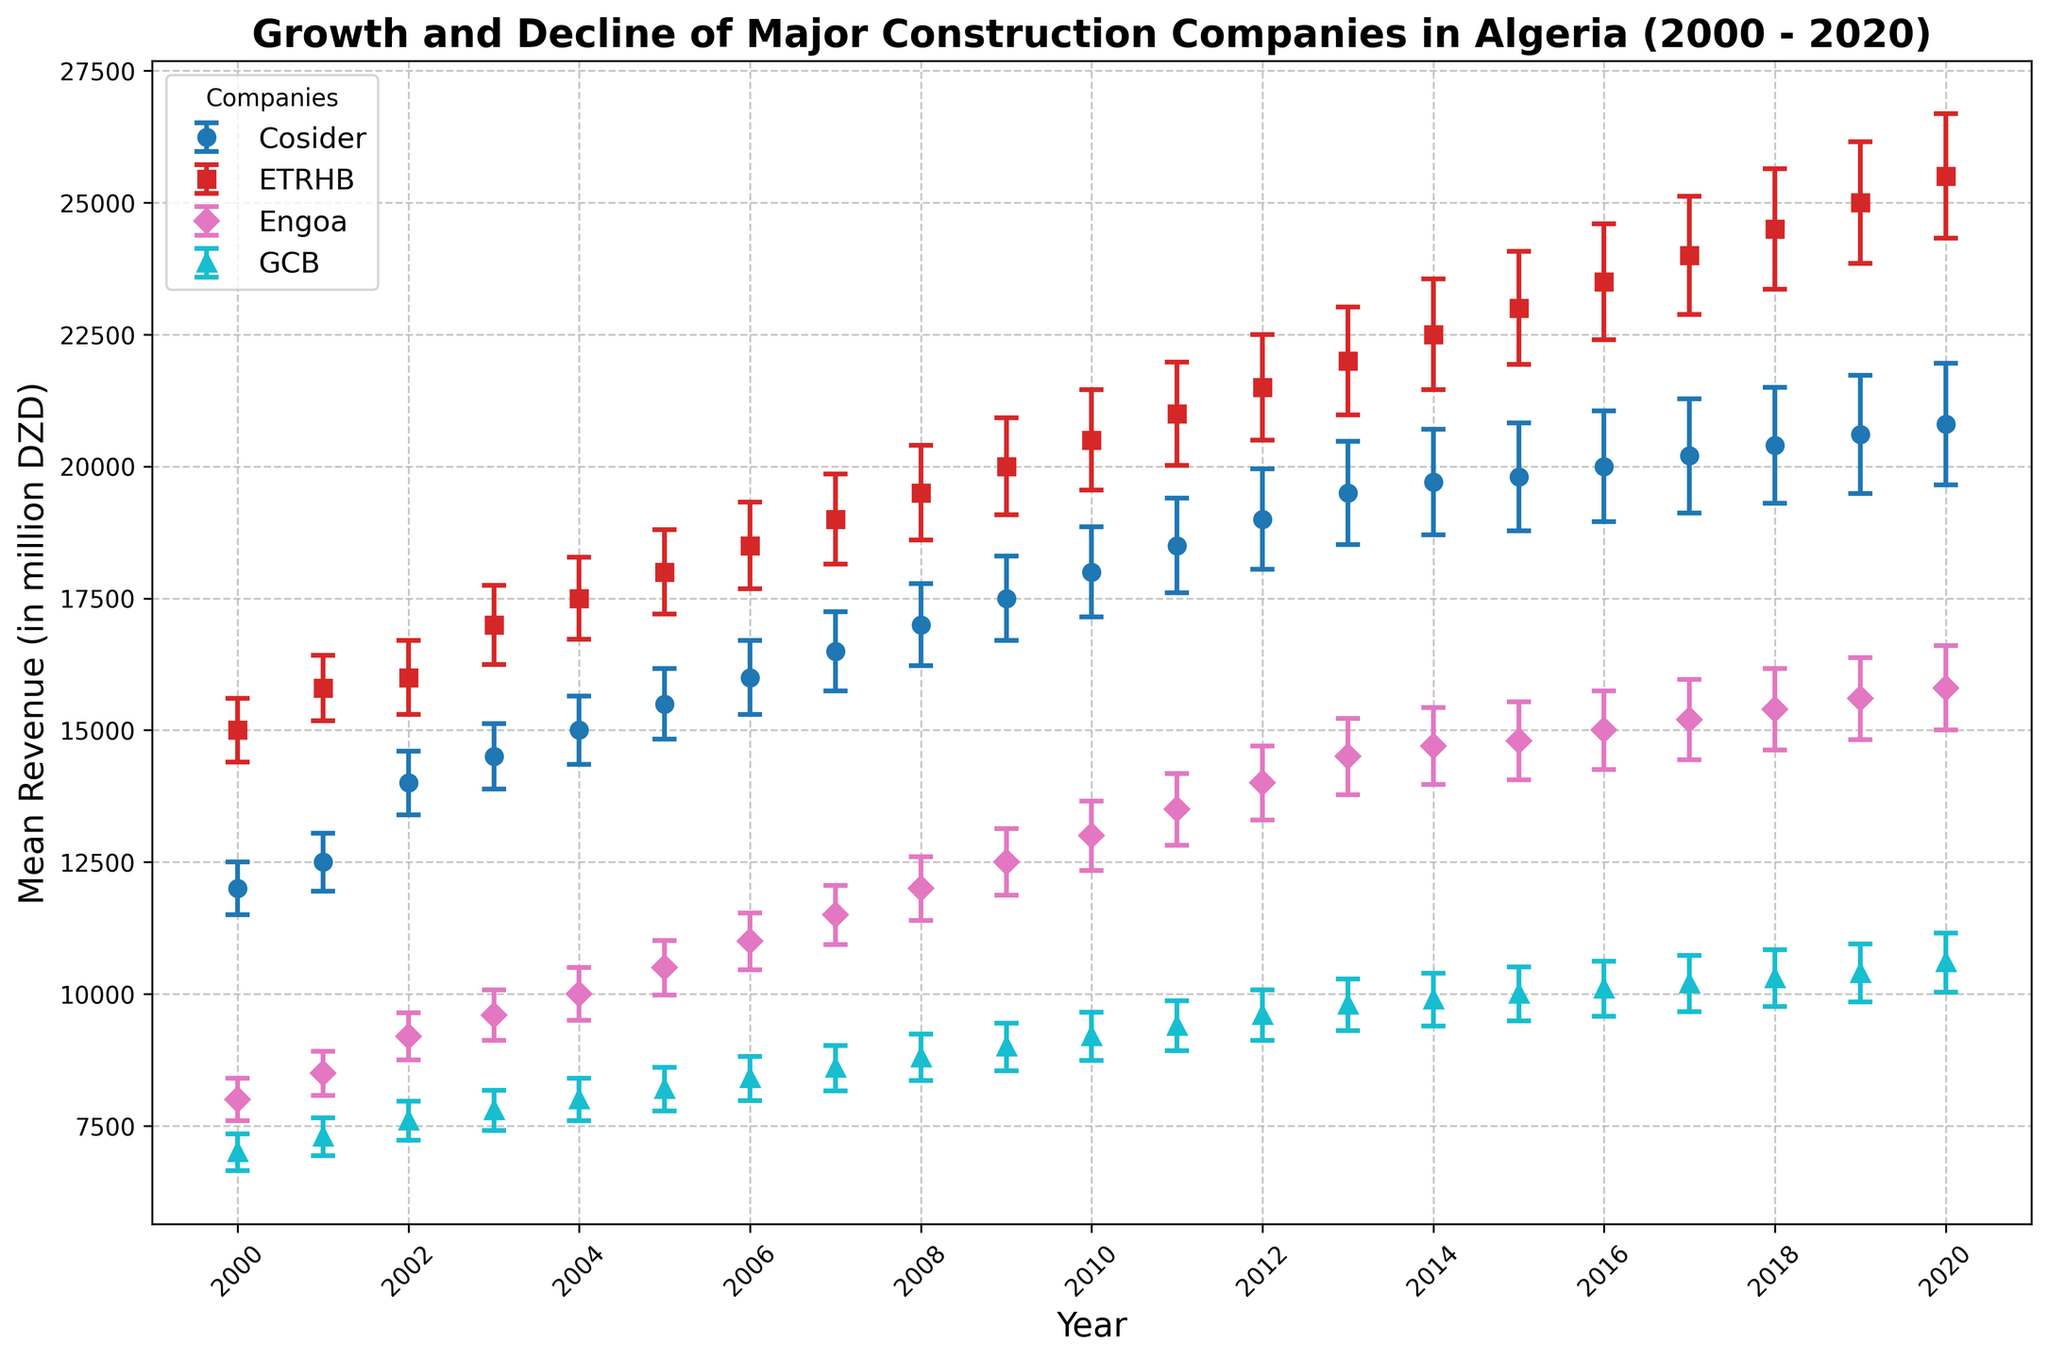Which company had the highest mean revenue in 2020? To determine this, I looked at the 2020 data points for all companies and identified the company with the highest mean revenue value. From the figure, ETRHB had the highest mean revenue in 2020.
Answer: ETRHB Between 2005 and 2010, which company showed the largest increase in mean revenue? I first identified the mean revenues for 2005 and 2010 for each company. Then I calculated the difference for each company and compared them. ETRHB's revenue increased from 18000 million DZD in 2005 to 20500 million DZD in 2010, showing an increase of 2500 million DZD, which is the largest.
Answer: ETRHB What is the average mean revenue of Cosider from 2000 to 2020? I summed up Cosider's mean revenues for each year from 2000 to 2020 and divided by the number of years (21). The calculation is (12000 + 12500 + 14000 + 14500 + 15000 + 15500 + 16000 + 16500 + 17000 + 17500 + 18000 + 18500 + 19000 + 19500 + 19700 + 19800 + 20000 + 20200 + 20400 + 20600 + 20800) / 21 = 17700 million DZD.
Answer: 17700 Which company has the smallest yearly revenue fluctuation (standard deviation) in 2008? I compared the revenue standard deviations of all companies for the year 2008 from the figure. Engoa had the smallest fluctuation with a standard deviation of 600 million DZD.
Answer: Engoa By approximately how much did GCB’s mean revenue increase from 2000 to 2020? I subtracted GCB's mean revenue in 2000 from its mean revenue in 2020. The calculation is 10600 million DZD (2020) - 7000 million DZD (2000) = 3600 million DZD.
Answer: 3600 Which company showed the most consistent revenue (smallest overall standard deviation) over the entire period? I compared the overall standard deviations for all companies across the years by observing their yearly standard deviations in the plot. I found the company with the lowest overall variance in standard deviations, which is GCB.
Answer: GCB How did the mean revenue of Engoa in 2015 compare to its mean revenue in 2010? I checked Engoa's mean revenues for 2015 and 2010. Engoa's revenue in 2015 was 14800 million DZD, and in 2010 it was 13000 million DZD, indicating an increase.
Answer: Increased Identify the year with the largest revenue standard deviation for any company and name the company. I looked at all the error bars (representing standard deviations) in the plot and identified the largest one. In 2020, ETRHB has the largest revenue standard deviation of 1180 million DZD.
Answer: 2020, ETRHB Which two companies had the closest mean revenues in 2003 and what were their mean revenues? I observed the mean revenue values for all companies in 2003. Cosider and Engoa had the closest revenues of 14500 and 9600 million DZD respectively.
Answer: Cosider: 14500, Engoa: 9600 